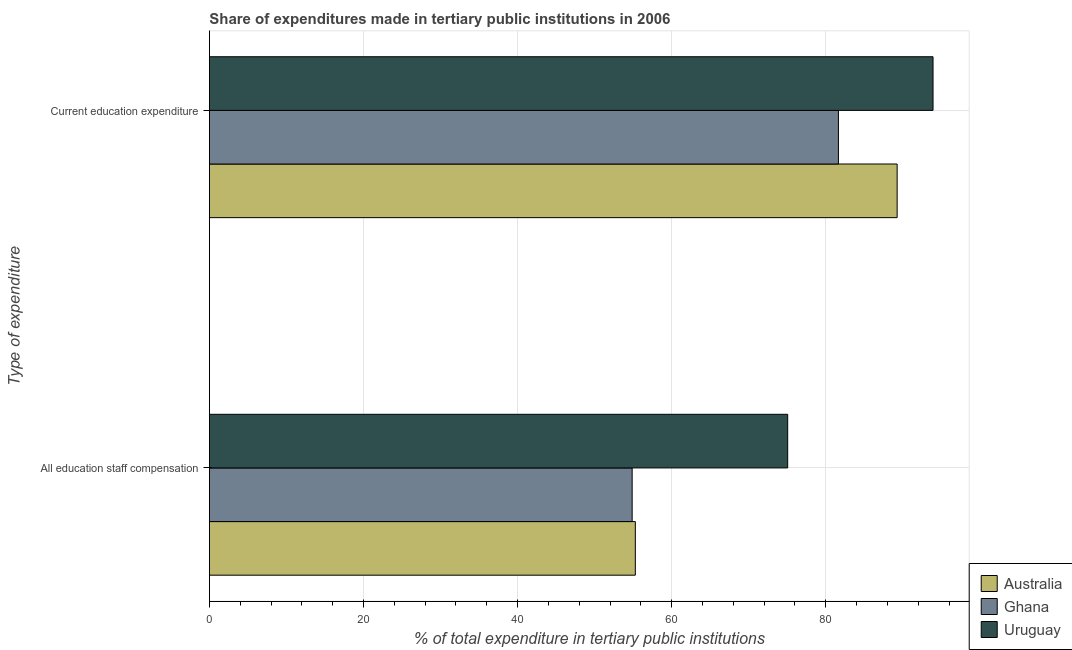How many bars are there on the 2nd tick from the top?
Provide a succinct answer. 3. How many bars are there on the 2nd tick from the bottom?
Your answer should be very brief. 3. What is the label of the 2nd group of bars from the top?
Offer a very short reply. All education staff compensation. What is the expenditure in staff compensation in Uruguay?
Make the answer very short. 75.06. Across all countries, what is the maximum expenditure in staff compensation?
Give a very brief answer. 75.06. Across all countries, what is the minimum expenditure in staff compensation?
Offer a terse response. 54.87. In which country was the expenditure in education maximum?
Your answer should be compact. Uruguay. What is the total expenditure in education in the graph?
Keep it short and to the point. 264.84. What is the difference between the expenditure in staff compensation in Uruguay and that in Ghana?
Offer a very short reply. 20.19. What is the difference between the expenditure in staff compensation in Ghana and the expenditure in education in Uruguay?
Your answer should be compact. -39.05. What is the average expenditure in education per country?
Ensure brevity in your answer.  88.28. What is the difference between the expenditure in staff compensation and expenditure in education in Uruguay?
Offer a terse response. -18.87. What is the ratio of the expenditure in education in Uruguay to that in Australia?
Ensure brevity in your answer.  1.05. Is the expenditure in staff compensation in Uruguay less than that in Ghana?
Keep it short and to the point. No. What does the 1st bar from the top in All education staff compensation represents?
Provide a succinct answer. Uruguay. What does the 3rd bar from the bottom in All education staff compensation represents?
Make the answer very short. Uruguay. How many bars are there?
Offer a terse response. 6. Are all the bars in the graph horizontal?
Make the answer very short. Yes. How many countries are there in the graph?
Make the answer very short. 3. What is the difference between two consecutive major ticks on the X-axis?
Provide a succinct answer. 20. Does the graph contain any zero values?
Make the answer very short. No. Does the graph contain grids?
Provide a succinct answer. Yes. Where does the legend appear in the graph?
Provide a short and direct response. Bottom right. How many legend labels are there?
Your response must be concise. 3. How are the legend labels stacked?
Your answer should be compact. Vertical. What is the title of the graph?
Keep it short and to the point. Share of expenditures made in tertiary public institutions in 2006. Does "Armenia" appear as one of the legend labels in the graph?
Provide a succinct answer. No. What is the label or title of the X-axis?
Provide a short and direct response. % of total expenditure in tertiary public institutions. What is the label or title of the Y-axis?
Offer a terse response. Type of expenditure. What is the % of total expenditure in tertiary public institutions in Australia in All education staff compensation?
Your response must be concise. 55.28. What is the % of total expenditure in tertiary public institutions in Ghana in All education staff compensation?
Keep it short and to the point. 54.87. What is the % of total expenditure in tertiary public institutions of Uruguay in All education staff compensation?
Your answer should be very brief. 75.06. What is the % of total expenditure in tertiary public institutions of Australia in Current education expenditure?
Your response must be concise. 89.27. What is the % of total expenditure in tertiary public institutions in Ghana in Current education expenditure?
Give a very brief answer. 81.65. What is the % of total expenditure in tertiary public institutions of Uruguay in Current education expenditure?
Provide a succinct answer. 93.93. Across all Type of expenditure, what is the maximum % of total expenditure in tertiary public institutions in Australia?
Your answer should be compact. 89.27. Across all Type of expenditure, what is the maximum % of total expenditure in tertiary public institutions of Ghana?
Offer a very short reply. 81.65. Across all Type of expenditure, what is the maximum % of total expenditure in tertiary public institutions of Uruguay?
Ensure brevity in your answer.  93.93. Across all Type of expenditure, what is the minimum % of total expenditure in tertiary public institutions of Australia?
Provide a short and direct response. 55.28. Across all Type of expenditure, what is the minimum % of total expenditure in tertiary public institutions in Ghana?
Keep it short and to the point. 54.87. Across all Type of expenditure, what is the minimum % of total expenditure in tertiary public institutions of Uruguay?
Offer a terse response. 75.06. What is the total % of total expenditure in tertiary public institutions in Australia in the graph?
Keep it short and to the point. 144.55. What is the total % of total expenditure in tertiary public institutions of Ghana in the graph?
Provide a succinct answer. 136.52. What is the total % of total expenditure in tertiary public institutions of Uruguay in the graph?
Your response must be concise. 168.99. What is the difference between the % of total expenditure in tertiary public institutions of Australia in All education staff compensation and that in Current education expenditure?
Provide a short and direct response. -33.98. What is the difference between the % of total expenditure in tertiary public institutions in Ghana in All education staff compensation and that in Current education expenditure?
Your response must be concise. -26.77. What is the difference between the % of total expenditure in tertiary public institutions of Uruguay in All education staff compensation and that in Current education expenditure?
Keep it short and to the point. -18.87. What is the difference between the % of total expenditure in tertiary public institutions of Australia in All education staff compensation and the % of total expenditure in tertiary public institutions of Ghana in Current education expenditure?
Offer a very short reply. -26.36. What is the difference between the % of total expenditure in tertiary public institutions in Australia in All education staff compensation and the % of total expenditure in tertiary public institutions in Uruguay in Current education expenditure?
Give a very brief answer. -38.64. What is the difference between the % of total expenditure in tertiary public institutions in Ghana in All education staff compensation and the % of total expenditure in tertiary public institutions in Uruguay in Current education expenditure?
Provide a succinct answer. -39.05. What is the average % of total expenditure in tertiary public institutions in Australia per Type of expenditure?
Your answer should be compact. 72.28. What is the average % of total expenditure in tertiary public institutions in Ghana per Type of expenditure?
Your answer should be very brief. 68.26. What is the average % of total expenditure in tertiary public institutions in Uruguay per Type of expenditure?
Provide a short and direct response. 84.49. What is the difference between the % of total expenditure in tertiary public institutions in Australia and % of total expenditure in tertiary public institutions in Ghana in All education staff compensation?
Your answer should be compact. 0.41. What is the difference between the % of total expenditure in tertiary public institutions of Australia and % of total expenditure in tertiary public institutions of Uruguay in All education staff compensation?
Ensure brevity in your answer.  -19.78. What is the difference between the % of total expenditure in tertiary public institutions of Ghana and % of total expenditure in tertiary public institutions of Uruguay in All education staff compensation?
Keep it short and to the point. -20.19. What is the difference between the % of total expenditure in tertiary public institutions of Australia and % of total expenditure in tertiary public institutions of Ghana in Current education expenditure?
Offer a terse response. 7.62. What is the difference between the % of total expenditure in tertiary public institutions in Australia and % of total expenditure in tertiary public institutions in Uruguay in Current education expenditure?
Ensure brevity in your answer.  -4.66. What is the difference between the % of total expenditure in tertiary public institutions of Ghana and % of total expenditure in tertiary public institutions of Uruguay in Current education expenditure?
Provide a succinct answer. -12.28. What is the ratio of the % of total expenditure in tertiary public institutions in Australia in All education staff compensation to that in Current education expenditure?
Provide a short and direct response. 0.62. What is the ratio of the % of total expenditure in tertiary public institutions of Ghana in All education staff compensation to that in Current education expenditure?
Your answer should be very brief. 0.67. What is the ratio of the % of total expenditure in tertiary public institutions of Uruguay in All education staff compensation to that in Current education expenditure?
Make the answer very short. 0.8. What is the difference between the highest and the second highest % of total expenditure in tertiary public institutions of Australia?
Make the answer very short. 33.98. What is the difference between the highest and the second highest % of total expenditure in tertiary public institutions in Ghana?
Your response must be concise. 26.77. What is the difference between the highest and the second highest % of total expenditure in tertiary public institutions of Uruguay?
Your answer should be very brief. 18.87. What is the difference between the highest and the lowest % of total expenditure in tertiary public institutions in Australia?
Your response must be concise. 33.98. What is the difference between the highest and the lowest % of total expenditure in tertiary public institutions of Ghana?
Your response must be concise. 26.77. What is the difference between the highest and the lowest % of total expenditure in tertiary public institutions in Uruguay?
Make the answer very short. 18.87. 